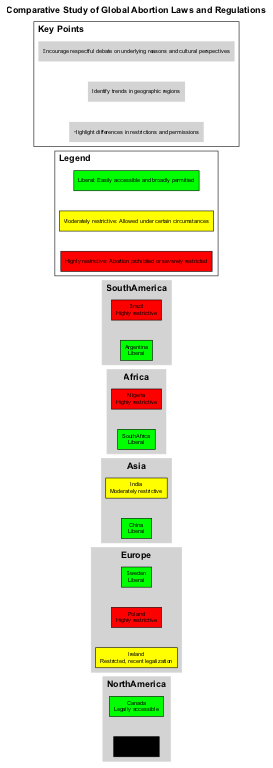What color represents Canada in the diagram? In the diagram, Canada is labeled under the North America region, and it states that its current status is "Color: Green." Therefore, Canada is represented visually by the green color in the diagram.
Answer: Green Which country has the most restrictive abortion law in Africa? Within the Africa region in the diagram, Nigeria is indicated as having a highly restrictive abortion law, only permitting it to save the woman's life. This establishes Nigeria as the most restrictive in this region.
Answer: Nigeria What is the regulation summary for Poland? The diagram states that Poland’s regulation summary indicates it is "Highly restrictive" regarding abortion laws, signifying severe limitations.
Answer: Highly restrictive What year was abortion legalized in Argentina? The diagram specifies that abortion was legalized in Argentina in the year 2020, providing a clear timeline for that event.
Answer: 2020 Which Asian country has a liberal abortion policy? In the Asia section of the diagram, China is highlighted as having a liberal abortion policy, making it one of the noted examples of such laws.
Answer: China How does the abortion law in Sweden differ from that in Ireland? Sweden's abortion law is categorized as "Liberal," allowing easy access, while Ireland's law is described as "Restricted," indicating stricter regulations. This comparison highlights the differences in policies between the two countries.
Answer: Sweden is liberal; Ireland is restricted What is the key point related to cultural perspectives? The diagram includes a key point that encourages "respectful debate on underlying reasons and cultural perspectives," suggesting that understanding cultural influences is important in discussions about abortion laws and regulations.
Answer: Respectful debate on cultural perspectives How many regions are represented in the diagram? There are five regions shown in the diagram, specifically North America, Europe, Asia, Africa, and South America, each containing various countries with different abortion laws.
Answer: Five Which country in South America has a highly restrictive law? The diagram highlights Brazil as having a highly restrictive abortion law, outlining that it is only permitted in cases of rape, anencephaly, or risk to the woman's life, thus marking it as restrictive.
Answer: Brazil 